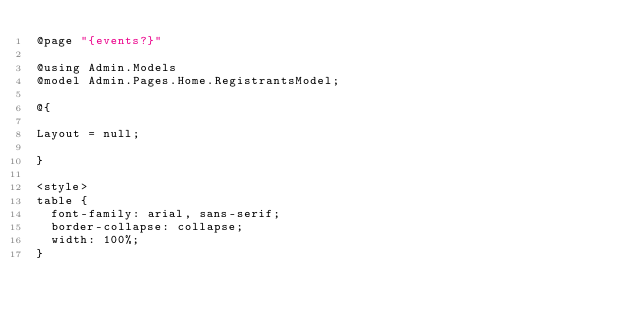<code> <loc_0><loc_0><loc_500><loc_500><_C#_>@page "{events?}"

@using Admin.Models
@model Admin.Pages.Home.RegistrantsModel;

@{

Layout = null;

}

<style>
table {
  font-family: arial, sans-serif;
  border-collapse: collapse;
  width: 100%;
}
</code> 